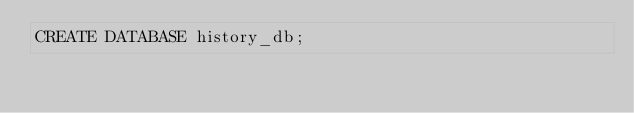Convert code to text. <code><loc_0><loc_0><loc_500><loc_500><_SQL_>CREATE DATABASE history_db;</code> 